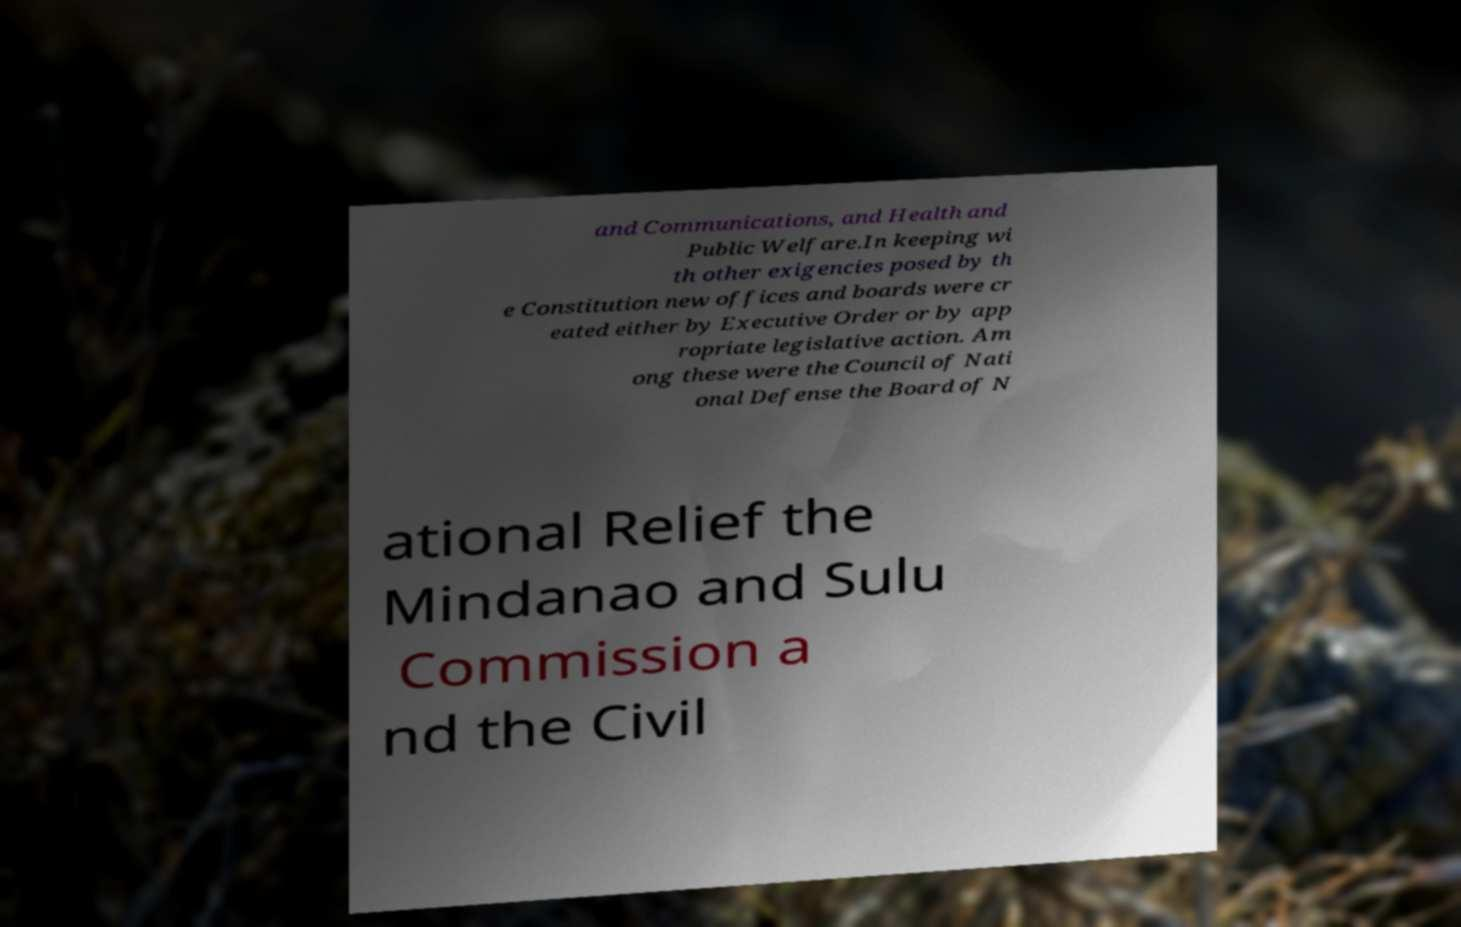I need the written content from this picture converted into text. Can you do that? and Communications, and Health and Public Welfare.In keeping wi th other exigencies posed by th e Constitution new offices and boards were cr eated either by Executive Order or by app ropriate legislative action. Am ong these were the Council of Nati onal Defense the Board of N ational Relief the Mindanao and Sulu Commission a nd the Civil 